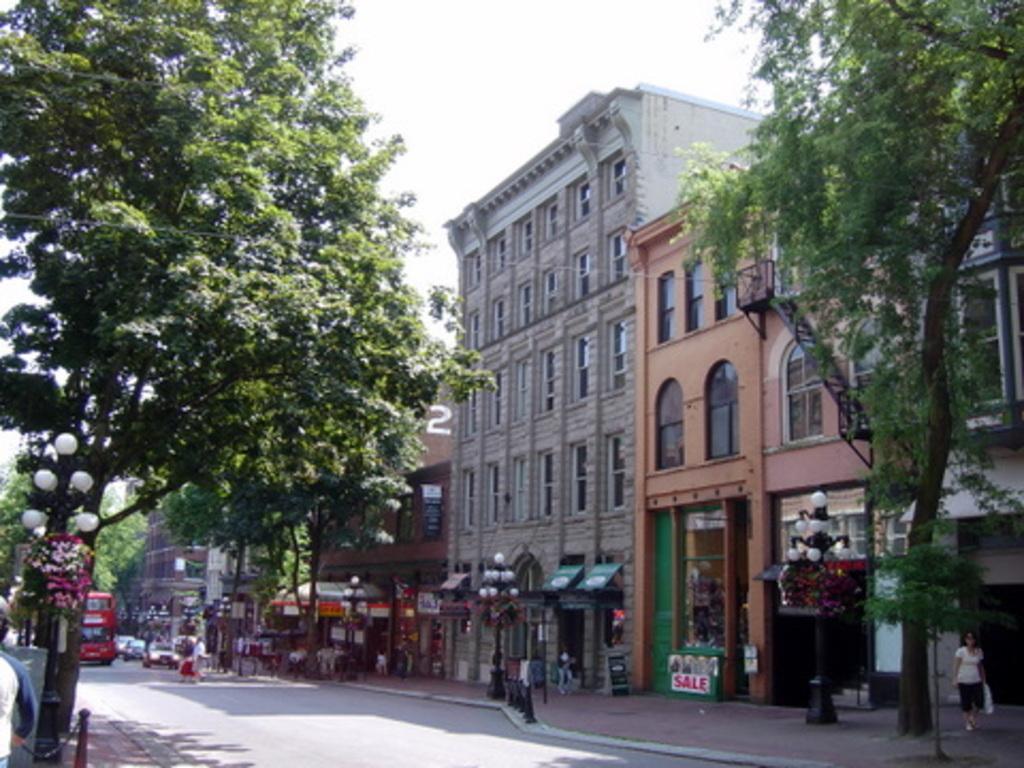Please provide a concise description of this image. In the center of the image we can see buildings, lights, stores, boards, poles are there. On the left side of the image we can see buses, cars, trees are present. At the bottom of the image road is there. At the top of the image sky is there. On the right side of the image a lady is walking and carrying a bag. 